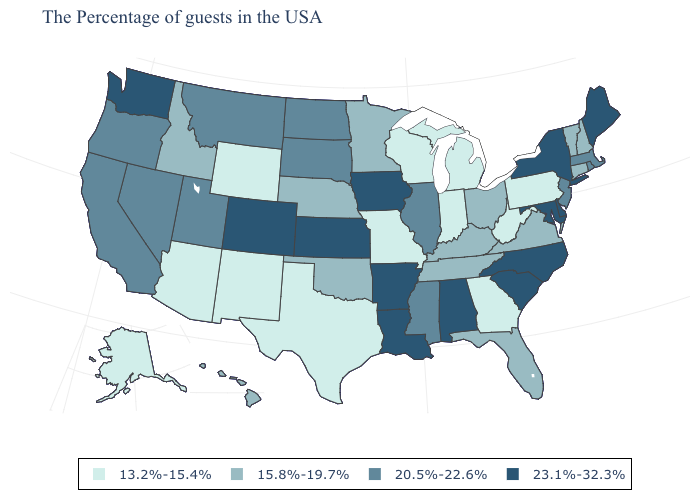Name the states that have a value in the range 13.2%-15.4%?
Give a very brief answer. Pennsylvania, West Virginia, Georgia, Michigan, Indiana, Wisconsin, Missouri, Texas, Wyoming, New Mexico, Arizona, Alaska. Which states have the highest value in the USA?
Short answer required. Maine, New York, Delaware, Maryland, North Carolina, South Carolina, Alabama, Louisiana, Arkansas, Iowa, Kansas, Colorado, Washington. What is the value of Arizona?
Write a very short answer. 13.2%-15.4%. Does Maine have the highest value in the USA?
Short answer required. Yes. What is the lowest value in the Northeast?
Write a very short answer. 13.2%-15.4%. What is the value of Michigan?
Keep it brief. 13.2%-15.4%. What is the lowest value in the Northeast?
Short answer required. 13.2%-15.4%. What is the value of Kentucky?
Short answer required. 15.8%-19.7%. Does Vermont have the same value as North Dakota?
Write a very short answer. No. Name the states that have a value in the range 20.5%-22.6%?
Write a very short answer. Massachusetts, Rhode Island, New Jersey, Illinois, Mississippi, South Dakota, North Dakota, Utah, Montana, Nevada, California, Oregon. Which states have the highest value in the USA?
Short answer required. Maine, New York, Delaware, Maryland, North Carolina, South Carolina, Alabama, Louisiana, Arkansas, Iowa, Kansas, Colorado, Washington. Which states have the lowest value in the USA?
Give a very brief answer. Pennsylvania, West Virginia, Georgia, Michigan, Indiana, Wisconsin, Missouri, Texas, Wyoming, New Mexico, Arizona, Alaska. Name the states that have a value in the range 20.5%-22.6%?
Concise answer only. Massachusetts, Rhode Island, New Jersey, Illinois, Mississippi, South Dakota, North Dakota, Utah, Montana, Nevada, California, Oregon. What is the lowest value in states that border Nebraska?
Concise answer only. 13.2%-15.4%. Name the states that have a value in the range 13.2%-15.4%?
Keep it brief. Pennsylvania, West Virginia, Georgia, Michigan, Indiana, Wisconsin, Missouri, Texas, Wyoming, New Mexico, Arizona, Alaska. 